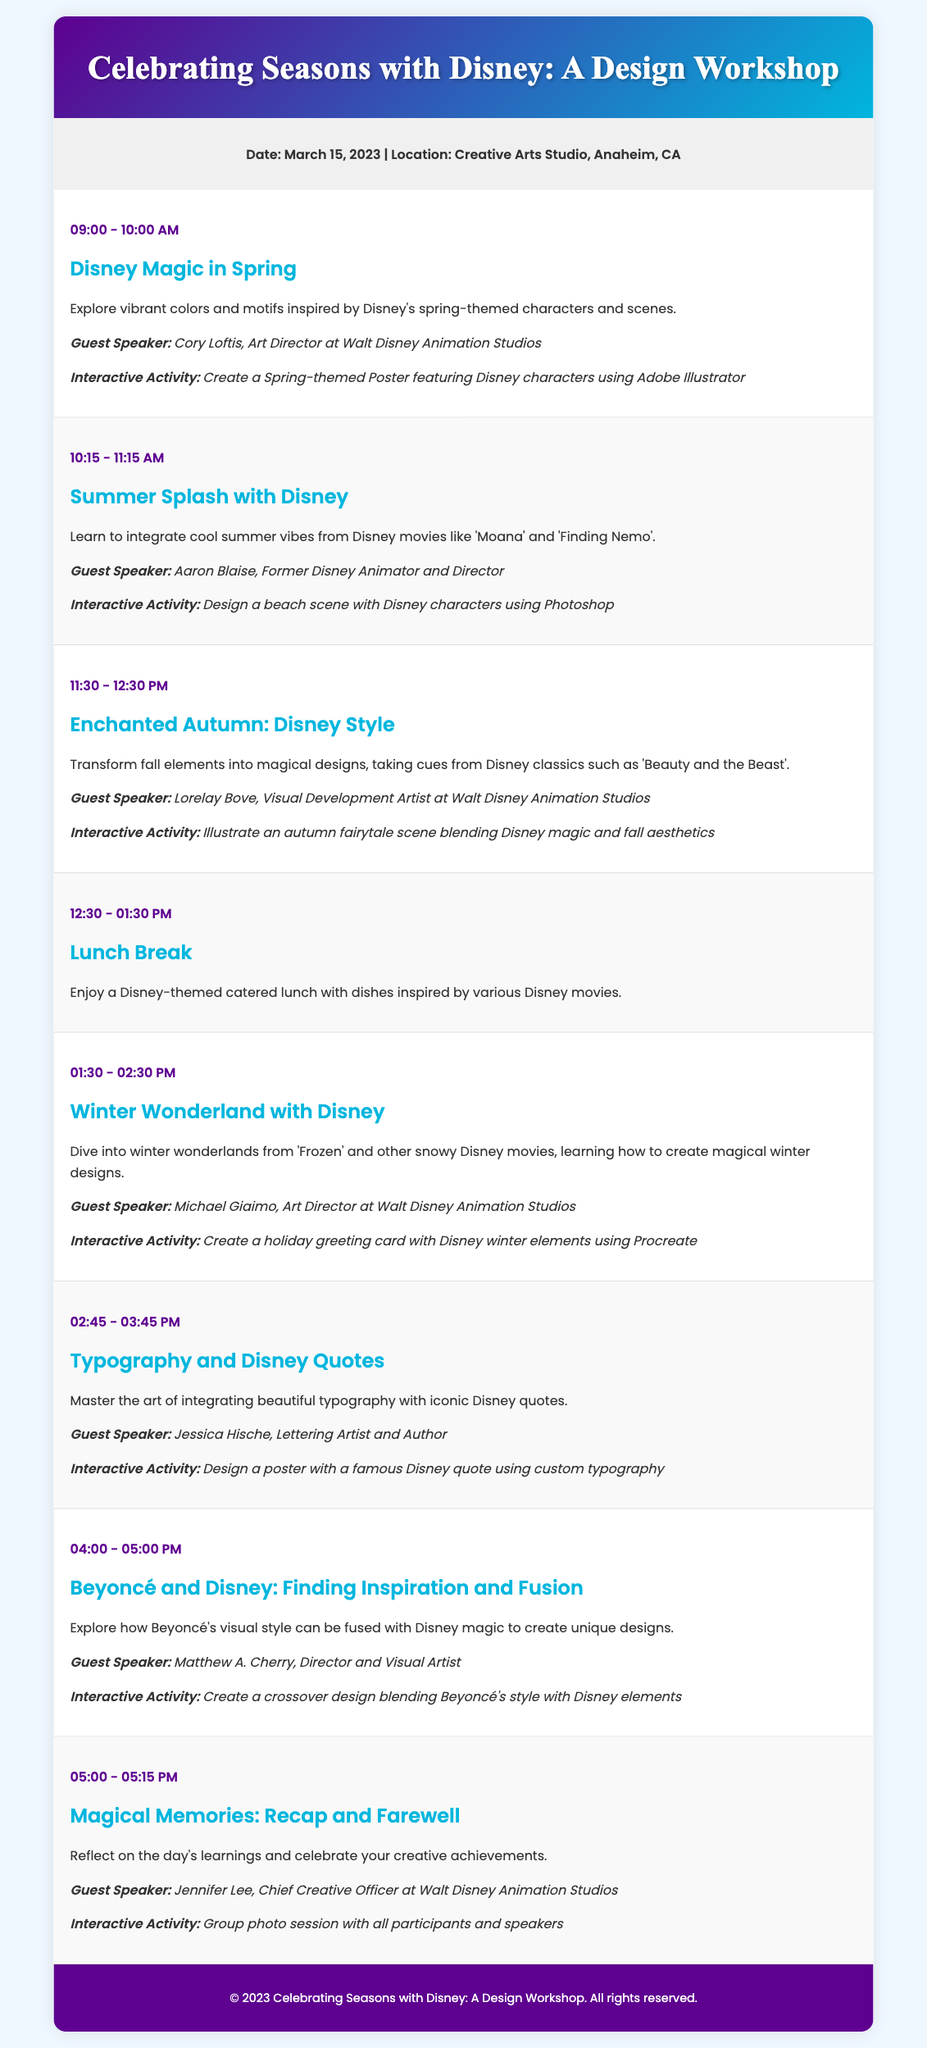what is the date of the workshop? The date is explicitly mentioned in the info section of the document.
Answer: March 15, 2023 where is the workshop located? The location is provided in the info section of the document.
Answer: Creative Arts Studio, Anaheim, CA who is the speaker for the session on Spring-themed design? The document lists the speaker associated with the Spring session.
Answer: Cory Loftis what time does the Winter Wonderland session start? The start time is specified in the session details for Winter Wonderland.
Answer: 01:30 PM name one interactive activity related to autumn designs. One activity is detailed in the session about autumn design within the document.
Answer: Illustrate an autumn fairytale scene blending Disney magic and fall aesthetics how many sessions are there in total? The total number of sessions can be counted from the sessions detailed in the document.
Answer: Seven which guest speaker focuses on typography? The speaker is associated with the Typography session listed in the document.
Answer: Jessica Hische what is the theme of the last session? The document details the theme of the final session.
Answer: Magical Memories: Recap and Farewell 